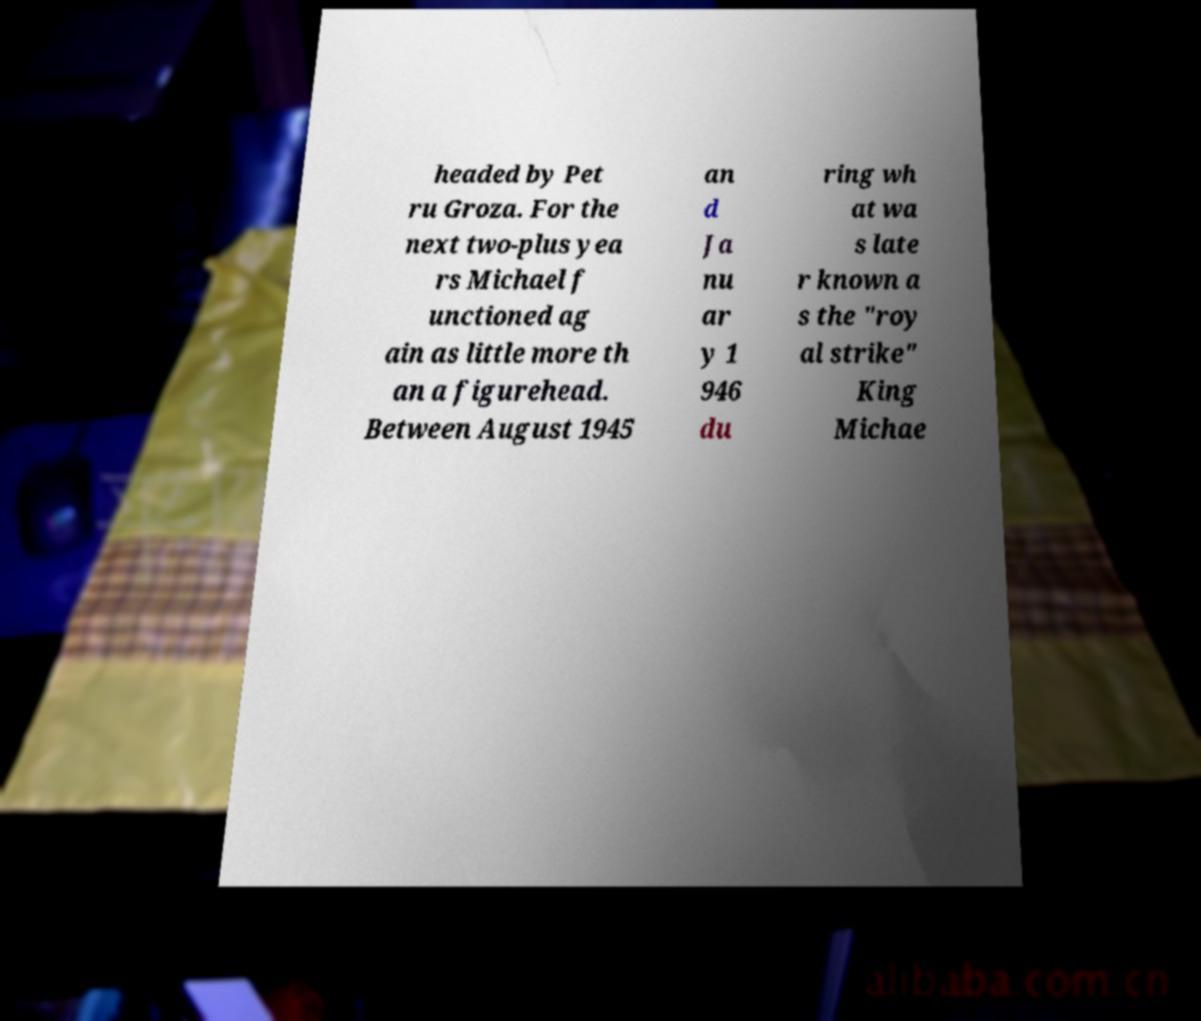Could you assist in decoding the text presented in this image and type it out clearly? headed by Pet ru Groza. For the next two-plus yea rs Michael f unctioned ag ain as little more th an a figurehead. Between August 1945 an d Ja nu ar y 1 946 du ring wh at wa s late r known a s the "roy al strike" King Michae 